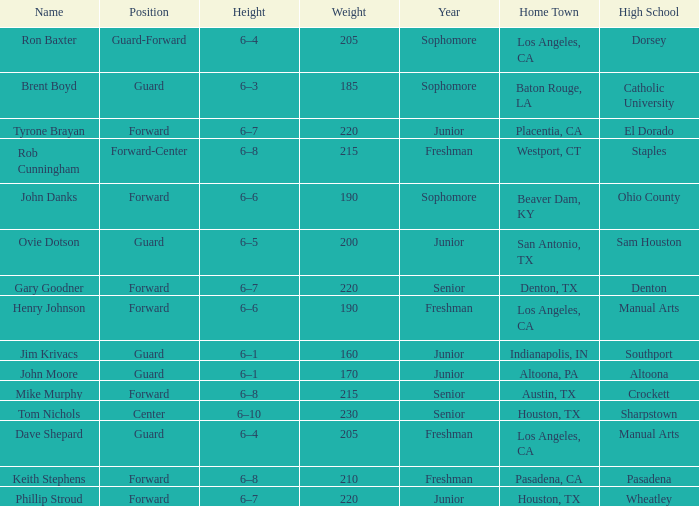What is the name including a year of an underclassman, and a high school related to wheatley? Phillip Stroud. 